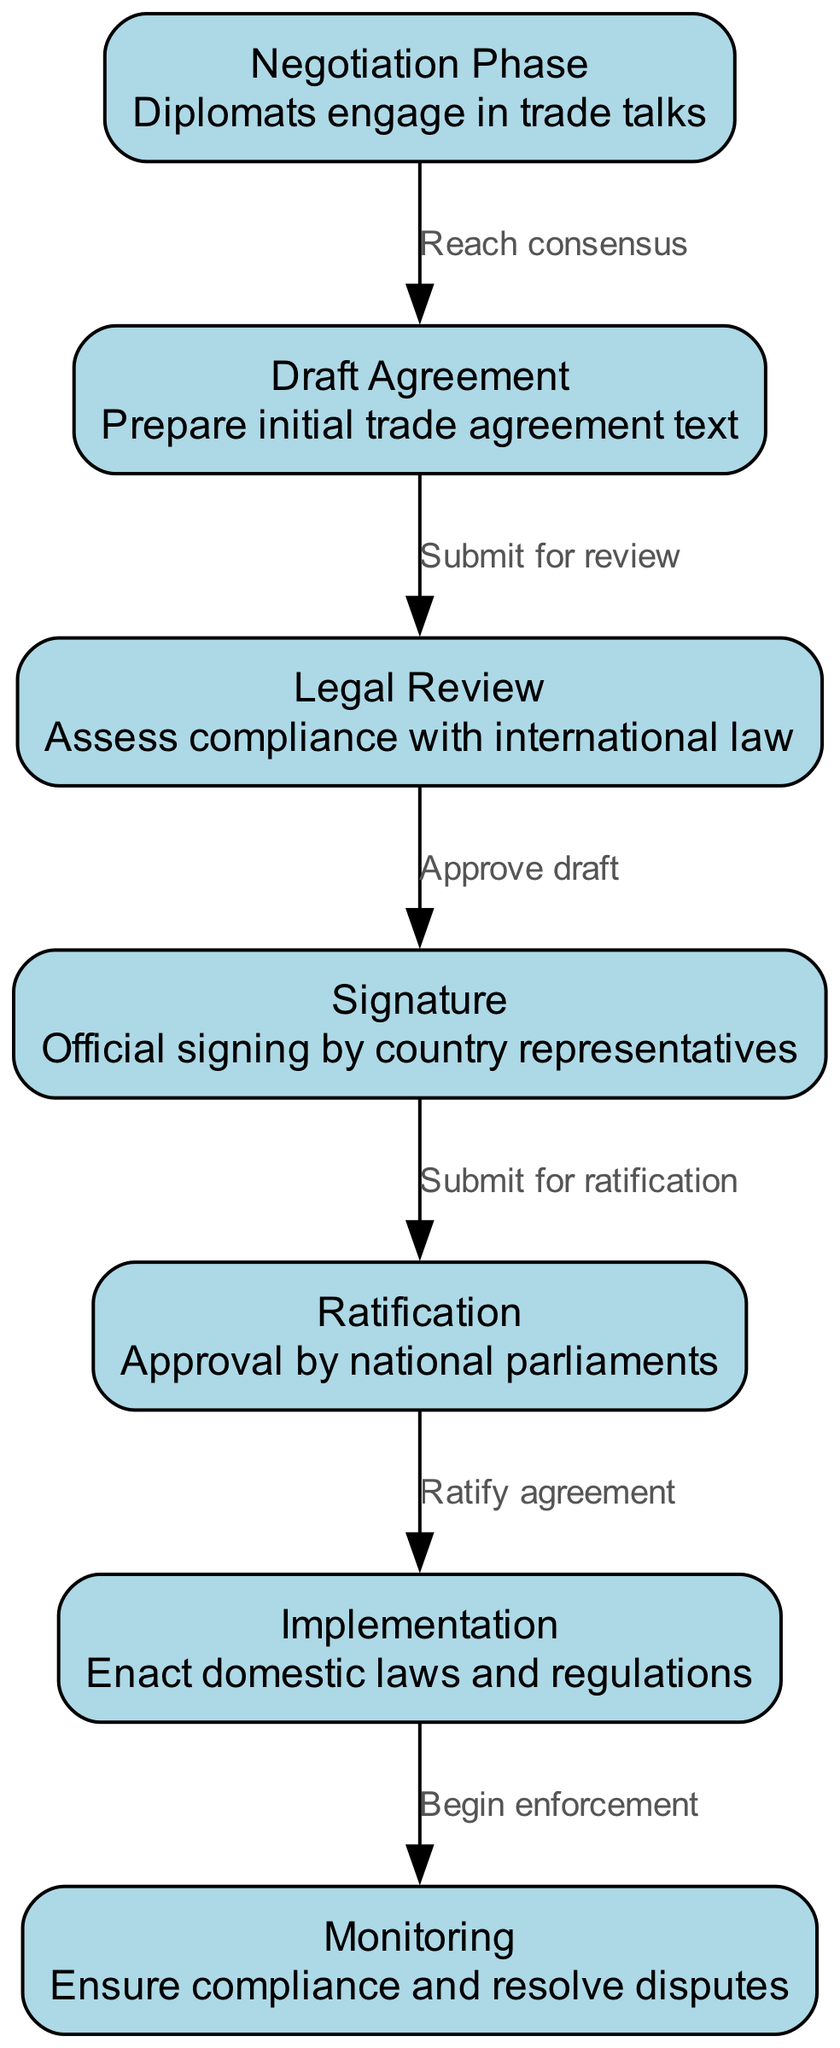What is the first phase in the diagram? The first phase is represented by the node with id "1", which is labeled "Negotiation Phase".
Answer: Negotiation Phase How many nodes are in the diagram? By counting the provided nodes, there are a total of 7 nodes listed in the data.
Answer: 7 What label is on the edge between "Draft Agreement" and "Legal Review"? The diagram shows that the label on this edge is "Submit for review", indicating the action taken to transition from "Draft Agreement" to "Legal Review".
Answer: Submit for review Which phase comes after "Ratification"? Following the "Ratification" phase, as indicated by the directed flow in the diagram, is the "Implementation" phase.
Answer: Implementation What does the "Monitoring" phase involve? The "Monitoring" phase is described in the diagram as ensuring compliance and resolving disputes, indicating its role in the enforcement of trade agreements.
Answer: Ensure compliance and resolve disputes What is required to transition from "Signature" to "Ratification"? The diagram indicates that the action to transition from "Signature" to "Ratification" is labeled "Submit for ratification".
Answer: Submit for ratification How many edges are there in the diagram? By counting the edges listed in the data, there are a total of 6 edges connecting the nodes in the diagram.
Answer: 6 What action follows the "Implementation" phase? The "Implementation" phase is followed by the "Monitoring" phase according to the flow of the diagram.
Answer: Monitoring Which node involves the assessment of compliance with international law? The node that describes the assessment of compliance with international law is identified as "Legal Review".
Answer: Legal Review 